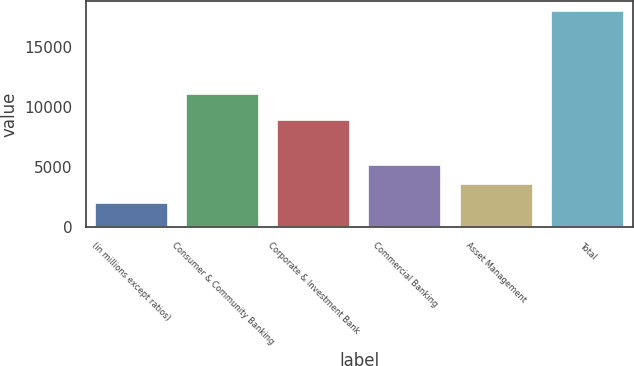Convert chart to OTSL. <chart><loc_0><loc_0><loc_500><loc_500><bar_chart><fcel>(in millions except ratios)<fcel>Consumer & Community Banking<fcel>Corporate & Investment Bank<fcel>Commercial Banking<fcel>Asset Management<fcel>Total<nl><fcel>2013<fcel>11061<fcel>8887<fcel>5195<fcel>3604<fcel>17923<nl></chart> 